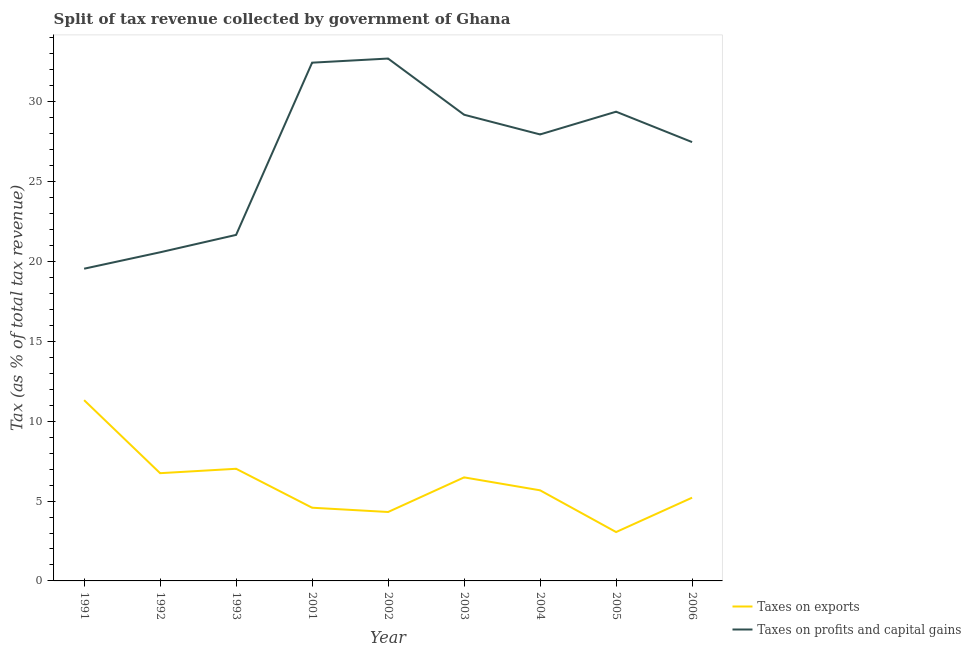How many different coloured lines are there?
Provide a succinct answer. 2. What is the percentage of revenue obtained from taxes on profits and capital gains in 1991?
Keep it short and to the point. 19.55. Across all years, what is the maximum percentage of revenue obtained from taxes on exports?
Provide a succinct answer. 11.32. Across all years, what is the minimum percentage of revenue obtained from taxes on profits and capital gains?
Your answer should be compact. 19.55. In which year was the percentage of revenue obtained from taxes on exports maximum?
Ensure brevity in your answer.  1991. What is the total percentage of revenue obtained from taxes on exports in the graph?
Offer a terse response. 54.41. What is the difference between the percentage of revenue obtained from taxes on exports in 1991 and that in 2005?
Provide a short and direct response. 8.26. What is the difference between the percentage of revenue obtained from taxes on exports in 1991 and the percentage of revenue obtained from taxes on profits and capital gains in 1993?
Give a very brief answer. -10.35. What is the average percentage of revenue obtained from taxes on exports per year?
Your answer should be compact. 6.05. In the year 1993, what is the difference between the percentage of revenue obtained from taxes on exports and percentage of revenue obtained from taxes on profits and capital gains?
Provide a short and direct response. -14.64. In how many years, is the percentage of revenue obtained from taxes on exports greater than 28 %?
Keep it short and to the point. 0. What is the ratio of the percentage of revenue obtained from taxes on profits and capital gains in 1993 to that in 2006?
Your answer should be compact. 0.79. Is the difference between the percentage of revenue obtained from taxes on exports in 1993 and 2005 greater than the difference between the percentage of revenue obtained from taxes on profits and capital gains in 1993 and 2005?
Give a very brief answer. Yes. What is the difference between the highest and the second highest percentage of revenue obtained from taxes on exports?
Make the answer very short. 4.3. What is the difference between the highest and the lowest percentage of revenue obtained from taxes on profits and capital gains?
Ensure brevity in your answer.  13.16. In how many years, is the percentage of revenue obtained from taxes on exports greater than the average percentage of revenue obtained from taxes on exports taken over all years?
Provide a succinct answer. 4. Does the percentage of revenue obtained from taxes on profits and capital gains monotonically increase over the years?
Make the answer very short. No. Is the percentage of revenue obtained from taxes on exports strictly greater than the percentage of revenue obtained from taxes on profits and capital gains over the years?
Ensure brevity in your answer.  No. Is the percentage of revenue obtained from taxes on exports strictly less than the percentage of revenue obtained from taxes on profits and capital gains over the years?
Give a very brief answer. Yes. How many lines are there?
Offer a terse response. 2. Does the graph contain grids?
Provide a short and direct response. No. Where does the legend appear in the graph?
Keep it short and to the point. Bottom right. How many legend labels are there?
Offer a terse response. 2. How are the legend labels stacked?
Ensure brevity in your answer.  Vertical. What is the title of the graph?
Your answer should be very brief. Split of tax revenue collected by government of Ghana. What is the label or title of the Y-axis?
Your answer should be compact. Tax (as % of total tax revenue). What is the Tax (as % of total tax revenue) of Taxes on exports in 1991?
Keep it short and to the point. 11.32. What is the Tax (as % of total tax revenue) in Taxes on profits and capital gains in 1991?
Keep it short and to the point. 19.55. What is the Tax (as % of total tax revenue) in Taxes on exports in 1992?
Your response must be concise. 6.75. What is the Tax (as % of total tax revenue) in Taxes on profits and capital gains in 1992?
Offer a very short reply. 20.57. What is the Tax (as % of total tax revenue) in Taxes on exports in 1993?
Provide a short and direct response. 7.02. What is the Tax (as % of total tax revenue) of Taxes on profits and capital gains in 1993?
Keep it short and to the point. 21.66. What is the Tax (as % of total tax revenue) of Taxes on exports in 2001?
Provide a short and direct response. 4.58. What is the Tax (as % of total tax revenue) of Taxes on profits and capital gains in 2001?
Provide a short and direct response. 32.45. What is the Tax (as % of total tax revenue) in Taxes on exports in 2002?
Provide a short and direct response. 4.32. What is the Tax (as % of total tax revenue) in Taxes on profits and capital gains in 2002?
Keep it short and to the point. 32.7. What is the Tax (as % of total tax revenue) of Taxes on exports in 2003?
Provide a succinct answer. 6.48. What is the Tax (as % of total tax revenue) in Taxes on profits and capital gains in 2003?
Give a very brief answer. 29.19. What is the Tax (as % of total tax revenue) in Taxes on exports in 2004?
Provide a succinct answer. 5.67. What is the Tax (as % of total tax revenue) of Taxes on profits and capital gains in 2004?
Ensure brevity in your answer.  27.95. What is the Tax (as % of total tax revenue) in Taxes on exports in 2005?
Your answer should be very brief. 3.06. What is the Tax (as % of total tax revenue) in Taxes on profits and capital gains in 2005?
Offer a very short reply. 29.38. What is the Tax (as % of total tax revenue) in Taxes on exports in 2006?
Offer a very short reply. 5.21. What is the Tax (as % of total tax revenue) of Taxes on profits and capital gains in 2006?
Keep it short and to the point. 27.47. Across all years, what is the maximum Tax (as % of total tax revenue) of Taxes on exports?
Ensure brevity in your answer.  11.32. Across all years, what is the maximum Tax (as % of total tax revenue) in Taxes on profits and capital gains?
Your answer should be compact. 32.7. Across all years, what is the minimum Tax (as % of total tax revenue) of Taxes on exports?
Make the answer very short. 3.06. Across all years, what is the minimum Tax (as % of total tax revenue) of Taxes on profits and capital gains?
Offer a very short reply. 19.55. What is the total Tax (as % of total tax revenue) of Taxes on exports in the graph?
Offer a terse response. 54.41. What is the total Tax (as % of total tax revenue) of Taxes on profits and capital gains in the graph?
Make the answer very short. 240.93. What is the difference between the Tax (as % of total tax revenue) in Taxes on exports in 1991 and that in 1992?
Offer a very short reply. 4.57. What is the difference between the Tax (as % of total tax revenue) of Taxes on profits and capital gains in 1991 and that in 1992?
Your answer should be very brief. -1.03. What is the difference between the Tax (as % of total tax revenue) in Taxes on exports in 1991 and that in 1993?
Your answer should be very brief. 4.3. What is the difference between the Tax (as % of total tax revenue) of Taxes on profits and capital gains in 1991 and that in 1993?
Give a very brief answer. -2.12. What is the difference between the Tax (as % of total tax revenue) in Taxes on exports in 1991 and that in 2001?
Offer a very short reply. 6.73. What is the difference between the Tax (as % of total tax revenue) in Taxes on profits and capital gains in 1991 and that in 2001?
Provide a succinct answer. -12.9. What is the difference between the Tax (as % of total tax revenue) of Taxes on exports in 1991 and that in 2002?
Your response must be concise. 7. What is the difference between the Tax (as % of total tax revenue) in Taxes on profits and capital gains in 1991 and that in 2002?
Keep it short and to the point. -13.16. What is the difference between the Tax (as % of total tax revenue) of Taxes on exports in 1991 and that in 2003?
Ensure brevity in your answer.  4.83. What is the difference between the Tax (as % of total tax revenue) of Taxes on profits and capital gains in 1991 and that in 2003?
Keep it short and to the point. -9.64. What is the difference between the Tax (as % of total tax revenue) of Taxes on exports in 1991 and that in 2004?
Provide a short and direct response. 5.64. What is the difference between the Tax (as % of total tax revenue) of Taxes on profits and capital gains in 1991 and that in 2004?
Offer a very short reply. -8.41. What is the difference between the Tax (as % of total tax revenue) of Taxes on exports in 1991 and that in 2005?
Give a very brief answer. 8.26. What is the difference between the Tax (as % of total tax revenue) of Taxes on profits and capital gains in 1991 and that in 2005?
Make the answer very short. -9.83. What is the difference between the Tax (as % of total tax revenue) of Taxes on exports in 1991 and that in 2006?
Your answer should be compact. 6.11. What is the difference between the Tax (as % of total tax revenue) of Taxes on profits and capital gains in 1991 and that in 2006?
Provide a succinct answer. -7.93. What is the difference between the Tax (as % of total tax revenue) in Taxes on exports in 1992 and that in 1993?
Offer a terse response. -0.28. What is the difference between the Tax (as % of total tax revenue) in Taxes on profits and capital gains in 1992 and that in 1993?
Provide a short and direct response. -1.09. What is the difference between the Tax (as % of total tax revenue) of Taxes on exports in 1992 and that in 2001?
Keep it short and to the point. 2.16. What is the difference between the Tax (as % of total tax revenue) of Taxes on profits and capital gains in 1992 and that in 2001?
Give a very brief answer. -11.87. What is the difference between the Tax (as % of total tax revenue) in Taxes on exports in 1992 and that in 2002?
Offer a very short reply. 2.43. What is the difference between the Tax (as % of total tax revenue) of Taxes on profits and capital gains in 1992 and that in 2002?
Your answer should be very brief. -12.13. What is the difference between the Tax (as % of total tax revenue) in Taxes on exports in 1992 and that in 2003?
Your answer should be compact. 0.26. What is the difference between the Tax (as % of total tax revenue) of Taxes on profits and capital gains in 1992 and that in 2003?
Provide a succinct answer. -8.61. What is the difference between the Tax (as % of total tax revenue) of Taxes on exports in 1992 and that in 2004?
Your response must be concise. 1.07. What is the difference between the Tax (as % of total tax revenue) in Taxes on profits and capital gains in 1992 and that in 2004?
Offer a very short reply. -7.38. What is the difference between the Tax (as % of total tax revenue) in Taxes on exports in 1992 and that in 2005?
Your response must be concise. 3.69. What is the difference between the Tax (as % of total tax revenue) of Taxes on profits and capital gains in 1992 and that in 2005?
Make the answer very short. -8.8. What is the difference between the Tax (as % of total tax revenue) in Taxes on exports in 1992 and that in 2006?
Your answer should be compact. 1.53. What is the difference between the Tax (as % of total tax revenue) in Taxes on profits and capital gains in 1992 and that in 2006?
Offer a very short reply. -6.9. What is the difference between the Tax (as % of total tax revenue) in Taxes on exports in 1993 and that in 2001?
Offer a very short reply. 2.44. What is the difference between the Tax (as % of total tax revenue) in Taxes on profits and capital gains in 1993 and that in 2001?
Keep it short and to the point. -10.78. What is the difference between the Tax (as % of total tax revenue) in Taxes on exports in 1993 and that in 2002?
Your answer should be very brief. 2.71. What is the difference between the Tax (as % of total tax revenue) in Taxes on profits and capital gains in 1993 and that in 2002?
Your response must be concise. -11.04. What is the difference between the Tax (as % of total tax revenue) in Taxes on exports in 1993 and that in 2003?
Provide a short and direct response. 0.54. What is the difference between the Tax (as % of total tax revenue) in Taxes on profits and capital gains in 1993 and that in 2003?
Provide a succinct answer. -7.52. What is the difference between the Tax (as % of total tax revenue) of Taxes on exports in 1993 and that in 2004?
Keep it short and to the point. 1.35. What is the difference between the Tax (as % of total tax revenue) of Taxes on profits and capital gains in 1993 and that in 2004?
Offer a terse response. -6.29. What is the difference between the Tax (as % of total tax revenue) in Taxes on exports in 1993 and that in 2005?
Your response must be concise. 3.96. What is the difference between the Tax (as % of total tax revenue) in Taxes on profits and capital gains in 1993 and that in 2005?
Your response must be concise. -7.71. What is the difference between the Tax (as % of total tax revenue) of Taxes on exports in 1993 and that in 2006?
Offer a very short reply. 1.81. What is the difference between the Tax (as % of total tax revenue) in Taxes on profits and capital gains in 1993 and that in 2006?
Your answer should be compact. -5.81. What is the difference between the Tax (as % of total tax revenue) in Taxes on exports in 2001 and that in 2002?
Ensure brevity in your answer.  0.27. What is the difference between the Tax (as % of total tax revenue) in Taxes on profits and capital gains in 2001 and that in 2002?
Keep it short and to the point. -0.26. What is the difference between the Tax (as % of total tax revenue) of Taxes on exports in 2001 and that in 2003?
Your answer should be compact. -1.9. What is the difference between the Tax (as % of total tax revenue) of Taxes on profits and capital gains in 2001 and that in 2003?
Keep it short and to the point. 3.26. What is the difference between the Tax (as % of total tax revenue) of Taxes on exports in 2001 and that in 2004?
Provide a succinct answer. -1.09. What is the difference between the Tax (as % of total tax revenue) in Taxes on profits and capital gains in 2001 and that in 2004?
Make the answer very short. 4.49. What is the difference between the Tax (as % of total tax revenue) of Taxes on exports in 2001 and that in 2005?
Offer a very short reply. 1.52. What is the difference between the Tax (as % of total tax revenue) of Taxes on profits and capital gains in 2001 and that in 2005?
Provide a short and direct response. 3.07. What is the difference between the Tax (as % of total tax revenue) of Taxes on exports in 2001 and that in 2006?
Make the answer very short. -0.63. What is the difference between the Tax (as % of total tax revenue) of Taxes on profits and capital gains in 2001 and that in 2006?
Offer a terse response. 4.97. What is the difference between the Tax (as % of total tax revenue) in Taxes on exports in 2002 and that in 2003?
Your answer should be very brief. -2.17. What is the difference between the Tax (as % of total tax revenue) in Taxes on profits and capital gains in 2002 and that in 2003?
Ensure brevity in your answer.  3.52. What is the difference between the Tax (as % of total tax revenue) of Taxes on exports in 2002 and that in 2004?
Your answer should be compact. -1.36. What is the difference between the Tax (as % of total tax revenue) in Taxes on profits and capital gains in 2002 and that in 2004?
Offer a very short reply. 4.75. What is the difference between the Tax (as % of total tax revenue) in Taxes on exports in 2002 and that in 2005?
Ensure brevity in your answer.  1.26. What is the difference between the Tax (as % of total tax revenue) of Taxes on profits and capital gains in 2002 and that in 2005?
Your response must be concise. 3.33. What is the difference between the Tax (as % of total tax revenue) in Taxes on exports in 2002 and that in 2006?
Give a very brief answer. -0.9. What is the difference between the Tax (as % of total tax revenue) of Taxes on profits and capital gains in 2002 and that in 2006?
Provide a succinct answer. 5.23. What is the difference between the Tax (as % of total tax revenue) of Taxes on exports in 2003 and that in 2004?
Offer a very short reply. 0.81. What is the difference between the Tax (as % of total tax revenue) of Taxes on profits and capital gains in 2003 and that in 2004?
Your answer should be very brief. 1.23. What is the difference between the Tax (as % of total tax revenue) of Taxes on exports in 2003 and that in 2005?
Offer a very short reply. 3.42. What is the difference between the Tax (as % of total tax revenue) in Taxes on profits and capital gains in 2003 and that in 2005?
Ensure brevity in your answer.  -0.19. What is the difference between the Tax (as % of total tax revenue) of Taxes on exports in 2003 and that in 2006?
Provide a succinct answer. 1.27. What is the difference between the Tax (as % of total tax revenue) of Taxes on profits and capital gains in 2003 and that in 2006?
Give a very brief answer. 1.71. What is the difference between the Tax (as % of total tax revenue) in Taxes on exports in 2004 and that in 2005?
Your answer should be compact. 2.61. What is the difference between the Tax (as % of total tax revenue) of Taxes on profits and capital gains in 2004 and that in 2005?
Offer a very short reply. -1.42. What is the difference between the Tax (as % of total tax revenue) in Taxes on exports in 2004 and that in 2006?
Offer a terse response. 0.46. What is the difference between the Tax (as % of total tax revenue) in Taxes on profits and capital gains in 2004 and that in 2006?
Your answer should be very brief. 0.48. What is the difference between the Tax (as % of total tax revenue) in Taxes on exports in 2005 and that in 2006?
Offer a terse response. -2.15. What is the difference between the Tax (as % of total tax revenue) in Taxes on profits and capital gains in 2005 and that in 2006?
Ensure brevity in your answer.  1.9. What is the difference between the Tax (as % of total tax revenue) in Taxes on exports in 1991 and the Tax (as % of total tax revenue) in Taxes on profits and capital gains in 1992?
Provide a short and direct response. -9.26. What is the difference between the Tax (as % of total tax revenue) of Taxes on exports in 1991 and the Tax (as % of total tax revenue) of Taxes on profits and capital gains in 1993?
Offer a terse response. -10.35. What is the difference between the Tax (as % of total tax revenue) of Taxes on exports in 1991 and the Tax (as % of total tax revenue) of Taxes on profits and capital gains in 2001?
Your response must be concise. -21.13. What is the difference between the Tax (as % of total tax revenue) in Taxes on exports in 1991 and the Tax (as % of total tax revenue) in Taxes on profits and capital gains in 2002?
Offer a terse response. -21.39. What is the difference between the Tax (as % of total tax revenue) of Taxes on exports in 1991 and the Tax (as % of total tax revenue) of Taxes on profits and capital gains in 2003?
Your answer should be compact. -17.87. What is the difference between the Tax (as % of total tax revenue) in Taxes on exports in 1991 and the Tax (as % of total tax revenue) in Taxes on profits and capital gains in 2004?
Ensure brevity in your answer.  -16.64. What is the difference between the Tax (as % of total tax revenue) in Taxes on exports in 1991 and the Tax (as % of total tax revenue) in Taxes on profits and capital gains in 2005?
Your answer should be compact. -18.06. What is the difference between the Tax (as % of total tax revenue) of Taxes on exports in 1991 and the Tax (as % of total tax revenue) of Taxes on profits and capital gains in 2006?
Offer a terse response. -16.16. What is the difference between the Tax (as % of total tax revenue) in Taxes on exports in 1992 and the Tax (as % of total tax revenue) in Taxes on profits and capital gains in 1993?
Give a very brief answer. -14.92. What is the difference between the Tax (as % of total tax revenue) of Taxes on exports in 1992 and the Tax (as % of total tax revenue) of Taxes on profits and capital gains in 2001?
Your answer should be compact. -25.7. What is the difference between the Tax (as % of total tax revenue) of Taxes on exports in 1992 and the Tax (as % of total tax revenue) of Taxes on profits and capital gains in 2002?
Provide a short and direct response. -25.96. What is the difference between the Tax (as % of total tax revenue) of Taxes on exports in 1992 and the Tax (as % of total tax revenue) of Taxes on profits and capital gains in 2003?
Give a very brief answer. -22.44. What is the difference between the Tax (as % of total tax revenue) in Taxes on exports in 1992 and the Tax (as % of total tax revenue) in Taxes on profits and capital gains in 2004?
Your response must be concise. -21.21. What is the difference between the Tax (as % of total tax revenue) in Taxes on exports in 1992 and the Tax (as % of total tax revenue) in Taxes on profits and capital gains in 2005?
Provide a succinct answer. -22.63. What is the difference between the Tax (as % of total tax revenue) in Taxes on exports in 1992 and the Tax (as % of total tax revenue) in Taxes on profits and capital gains in 2006?
Provide a short and direct response. -20.73. What is the difference between the Tax (as % of total tax revenue) in Taxes on exports in 1993 and the Tax (as % of total tax revenue) in Taxes on profits and capital gains in 2001?
Provide a succinct answer. -25.43. What is the difference between the Tax (as % of total tax revenue) of Taxes on exports in 1993 and the Tax (as % of total tax revenue) of Taxes on profits and capital gains in 2002?
Ensure brevity in your answer.  -25.68. What is the difference between the Tax (as % of total tax revenue) in Taxes on exports in 1993 and the Tax (as % of total tax revenue) in Taxes on profits and capital gains in 2003?
Provide a short and direct response. -22.17. What is the difference between the Tax (as % of total tax revenue) of Taxes on exports in 1993 and the Tax (as % of total tax revenue) of Taxes on profits and capital gains in 2004?
Make the answer very short. -20.93. What is the difference between the Tax (as % of total tax revenue) in Taxes on exports in 1993 and the Tax (as % of total tax revenue) in Taxes on profits and capital gains in 2005?
Your answer should be compact. -22.36. What is the difference between the Tax (as % of total tax revenue) of Taxes on exports in 1993 and the Tax (as % of total tax revenue) of Taxes on profits and capital gains in 2006?
Make the answer very short. -20.45. What is the difference between the Tax (as % of total tax revenue) of Taxes on exports in 2001 and the Tax (as % of total tax revenue) of Taxes on profits and capital gains in 2002?
Ensure brevity in your answer.  -28.12. What is the difference between the Tax (as % of total tax revenue) of Taxes on exports in 2001 and the Tax (as % of total tax revenue) of Taxes on profits and capital gains in 2003?
Your answer should be very brief. -24.6. What is the difference between the Tax (as % of total tax revenue) in Taxes on exports in 2001 and the Tax (as % of total tax revenue) in Taxes on profits and capital gains in 2004?
Keep it short and to the point. -23.37. What is the difference between the Tax (as % of total tax revenue) of Taxes on exports in 2001 and the Tax (as % of total tax revenue) of Taxes on profits and capital gains in 2005?
Keep it short and to the point. -24.79. What is the difference between the Tax (as % of total tax revenue) of Taxes on exports in 2001 and the Tax (as % of total tax revenue) of Taxes on profits and capital gains in 2006?
Keep it short and to the point. -22.89. What is the difference between the Tax (as % of total tax revenue) in Taxes on exports in 2002 and the Tax (as % of total tax revenue) in Taxes on profits and capital gains in 2003?
Make the answer very short. -24.87. What is the difference between the Tax (as % of total tax revenue) in Taxes on exports in 2002 and the Tax (as % of total tax revenue) in Taxes on profits and capital gains in 2004?
Keep it short and to the point. -23.64. What is the difference between the Tax (as % of total tax revenue) in Taxes on exports in 2002 and the Tax (as % of total tax revenue) in Taxes on profits and capital gains in 2005?
Offer a terse response. -25.06. What is the difference between the Tax (as % of total tax revenue) of Taxes on exports in 2002 and the Tax (as % of total tax revenue) of Taxes on profits and capital gains in 2006?
Your answer should be very brief. -23.16. What is the difference between the Tax (as % of total tax revenue) of Taxes on exports in 2003 and the Tax (as % of total tax revenue) of Taxes on profits and capital gains in 2004?
Your response must be concise. -21.47. What is the difference between the Tax (as % of total tax revenue) in Taxes on exports in 2003 and the Tax (as % of total tax revenue) in Taxes on profits and capital gains in 2005?
Provide a succinct answer. -22.89. What is the difference between the Tax (as % of total tax revenue) in Taxes on exports in 2003 and the Tax (as % of total tax revenue) in Taxes on profits and capital gains in 2006?
Give a very brief answer. -20.99. What is the difference between the Tax (as % of total tax revenue) of Taxes on exports in 2004 and the Tax (as % of total tax revenue) of Taxes on profits and capital gains in 2005?
Provide a short and direct response. -23.7. What is the difference between the Tax (as % of total tax revenue) in Taxes on exports in 2004 and the Tax (as % of total tax revenue) in Taxes on profits and capital gains in 2006?
Give a very brief answer. -21.8. What is the difference between the Tax (as % of total tax revenue) of Taxes on exports in 2005 and the Tax (as % of total tax revenue) of Taxes on profits and capital gains in 2006?
Keep it short and to the point. -24.41. What is the average Tax (as % of total tax revenue) in Taxes on exports per year?
Offer a terse response. 6.05. What is the average Tax (as % of total tax revenue) in Taxes on profits and capital gains per year?
Your answer should be compact. 26.77. In the year 1991, what is the difference between the Tax (as % of total tax revenue) in Taxes on exports and Tax (as % of total tax revenue) in Taxes on profits and capital gains?
Provide a succinct answer. -8.23. In the year 1992, what is the difference between the Tax (as % of total tax revenue) in Taxes on exports and Tax (as % of total tax revenue) in Taxes on profits and capital gains?
Provide a succinct answer. -13.83. In the year 1993, what is the difference between the Tax (as % of total tax revenue) of Taxes on exports and Tax (as % of total tax revenue) of Taxes on profits and capital gains?
Offer a terse response. -14.64. In the year 2001, what is the difference between the Tax (as % of total tax revenue) in Taxes on exports and Tax (as % of total tax revenue) in Taxes on profits and capital gains?
Offer a very short reply. -27.86. In the year 2002, what is the difference between the Tax (as % of total tax revenue) in Taxes on exports and Tax (as % of total tax revenue) in Taxes on profits and capital gains?
Ensure brevity in your answer.  -28.39. In the year 2003, what is the difference between the Tax (as % of total tax revenue) in Taxes on exports and Tax (as % of total tax revenue) in Taxes on profits and capital gains?
Provide a succinct answer. -22.7. In the year 2004, what is the difference between the Tax (as % of total tax revenue) in Taxes on exports and Tax (as % of total tax revenue) in Taxes on profits and capital gains?
Give a very brief answer. -22.28. In the year 2005, what is the difference between the Tax (as % of total tax revenue) of Taxes on exports and Tax (as % of total tax revenue) of Taxes on profits and capital gains?
Give a very brief answer. -26.32. In the year 2006, what is the difference between the Tax (as % of total tax revenue) of Taxes on exports and Tax (as % of total tax revenue) of Taxes on profits and capital gains?
Provide a short and direct response. -22.26. What is the ratio of the Tax (as % of total tax revenue) of Taxes on exports in 1991 to that in 1992?
Your answer should be compact. 1.68. What is the ratio of the Tax (as % of total tax revenue) of Taxes on profits and capital gains in 1991 to that in 1992?
Ensure brevity in your answer.  0.95. What is the ratio of the Tax (as % of total tax revenue) in Taxes on exports in 1991 to that in 1993?
Give a very brief answer. 1.61. What is the ratio of the Tax (as % of total tax revenue) in Taxes on profits and capital gains in 1991 to that in 1993?
Ensure brevity in your answer.  0.9. What is the ratio of the Tax (as % of total tax revenue) in Taxes on exports in 1991 to that in 2001?
Your response must be concise. 2.47. What is the ratio of the Tax (as % of total tax revenue) in Taxes on profits and capital gains in 1991 to that in 2001?
Give a very brief answer. 0.6. What is the ratio of the Tax (as % of total tax revenue) of Taxes on exports in 1991 to that in 2002?
Make the answer very short. 2.62. What is the ratio of the Tax (as % of total tax revenue) in Taxes on profits and capital gains in 1991 to that in 2002?
Give a very brief answer. 0.6. What is the ratio of the Tax (as % of total tax revenue) in Taxes on exports in 1991 to that in 2003?
Keep it short and to the point. 1.75. What is the ratio of the Tax (as % of total tax revenue) in Taxes on profits and capital gains in 1991 to that in 2003?
Offer a terse response. 0.67. What is the ratio of the Tax (as % of total tax revenue) in Taxes on exports in 1991 to that in 2004?
Offer a very short reply. 1.99. What is the ratio of the Tax (as % of total tax revenue) in Taxes on profits and capital gains in 1991 to that in 2004?
Provide a short and direct response. 0.7. What is the ratio of the Tax (as % of total tax revenue) of Taxes on exports in 1991 to that in 2005?
Make the answer very short. 3.7. What is the ratio of the Tax (as % of total tax revenue) of Taxes on profits and capital gains in 1991 to that in 2005?
Give a very brief answer. 0.67. What is the ratio of the Tax (as % of total tax revenue) in Taxes on exports in 1991 to that in 2006?
Provide a succinct answer. 2.17. What is the ratio of the Tax (as % of total tax revenue) in Taxes on profits and capital gains in 1991 to that in 2006?
Your response must be concise. 0.71. What is the ratio of the Tax (as % of total tax revenue) in Taxes on exports in 1992 to that in 1993?
Make the answer very short. 0.96. What is the ratio of the Tax (as % of total tax revenue) of Taxes on profits and capital gains in 1992 to that in 1993?
Offer a very short reply. 0.95. What is the ratio of the Tax (as % of total tax revenue) of Taxes on exports in 1992 to that in 2001?
Your answer should be compact. 1.47. What is the ratio of the Tax (as % of total tax revenue) in Taxes on profits and capital gains in 1992 to that in 2001?
Your response must be concise. 0.63. What is the ratio of the Tax (as % of total tax revenue) of Taxes on exports in 1992 to that in 2002?
Provide a succinct answer. 1.56. What is the ratio of the Tax (as % of total tax revenue) in Taxes on profits and capital gains in 1992 to that in 2002?
Keep it short and to the point. 0.63. What is the ratio of the Tax (as % of total tax revenue) in Taxes on exports in 1992 to that in 2003?
Offer a terse response. 1.04. What is the ratio of the Tax (as % of total tax revenue) of Taxes on profits and capital gains in 1992 to that in 2003?
Provide a succinct answer. 0.7. What is the ratio of the Tax (as % of total tax revenue) in Taxes on exports in 1992 to that in 2004?
Provide a succinct answer. 1.19. What is the ratio of the Tax (as % of total tax revenue) in Taxes on profits and capital gains in 1992 to that in 2004?
Offer a very short reply. 0.74. What is the ratio of the Tax (as % of total tax revenue) in Taxes on exports in 1992 to that in 2005?
Keep it short and to the point. 2.2. What is the ratio of the Tax (as % of total tax revenue) in Taxes on profits and capital gains in 1992 to that in 2005?
Provide a succinct answer. 0.7. What is the ratio of the Tax (as % of total tax revenue) in Taxes on exports in 1992 to that in 2006?
Your response must be concise. 1.29. What is the ratio of the Tax (as % of total tax revenue) in Taxes on profits and capital gains in 1992 to that in 2006?
Keep it short and to the point. 0.75. What is the ratio of the Tax (as % of total tax revenue) of Taxes on exports in 1993 to that in 2001?
Provide a succinct answer. 1.53. What is the ratio of the Tax (as % of total tax revenue) of Taxes on profits and capital gains in 1993 to that in 2001?
Provide a succinct answer. 0.67. What is the ratio of the Tax (as % of total tax revenue) in Taxes on exports in 1993 to that in 2002?
Offer a very short reply. 1.63. What is the ratio of the Tax (as % of total tax revenue) in Taxes on profits and capital gains in 1993 to that in 2002?
Offer a terse response. 0.66. What is the ratio of the Tax (as % of total tax revenue) in Taxes on exports in 1993 to that in 2003?
Make the answer very short. 1.08. What is the ratio of the Tax (as % of total tax revenue) of Taxes on profits and capital gains in 1993 to that in 2003?
Provide a succinct answer. 0.74. What is the ratio of the Tax (as % of total tax revenue) in Taxes on exports in 1993 to that in 2004?
Provide a short and direct response. 1.24. What is the ratio of the Tax (as % of total tax revenue) of Taxes on profits and capital gains in 1993 to that in 2004?
Your answer should be very brief. 0.78. What is the ratio of the Tax (as % of total tax revenue) of Taxes on exports in 1993 to that in 2005?
Offer a very short reply. 2.29. What is the ratio of the Tax (as % of total tax revenue) of Taxes on profits and capital gains in 1993 to that in 2005?
Make the answer very short. 0.74. What is the ratio of the Tax (as % of total tax revenue) of Taxes on exports in 1993 to that in 2006?
Ensure brevity in your answer.  1.35. What is the ratio of the Tax (as % of total tax revenue) of Taxes on profits and capital gains in 1993 to that in 2006?
Provide a short and direct response. 0.79. What is the ratio of the Tax (as % of total tax revenue) of Taxes on exports in 2001 to that in 2002?
Provide a succinct answer. 1.06. What is the ratio of the Tax (as % of total tax revenue) in Taxes on profits and capital gains in 2001 to that in 2002?
Provide a succinct answer. 0.99. What is the ratio of the Tax (as % of total tax revenue) of Taxes on exports in 2001 to that in 2003?
Give a very brief answer. 0.71. What is the ratio of the Tax (as % of total tax revenue) of Taxes on profits and capital gains in 2001 to that in 2003?
Give a very brief answer. 1.11. What is the ratio of the Tax (as % of total tax revenue) in Taxes on exports in 2001 to that in 2004?
Provide a short and direct response. 0.81. What is the ratio of the Tax (as % of total tax revenue) in Taxes on profits and capital gains in 2001 to that in 2004?
Provide a short and direct response. 1.16. What is the ratio of the Tax (as % of total tax revenue) in Taxes on exports in 2001 to that in 2005?
Give a very brief answer. 1.5. What is the ratio of the Tax (as % of total tax revenue) in Taxes on profits and capital gains in 2001 to that in 2005?
Give a very brief answer. 1.1. What is the ratio of the Tax (as % of total tax revenue) of Taxes on exports in 2001 to that in 2006?
Give a very brief answer. 0.88. What is the ratio of the Tax (as % of total tax revenue) in Taxes on profits and capital gains in 2001 to that in 2006?
Give a very brief answer. 1.18. What is the ratio of the Tax (as % of total tax revenue) in Taxes on exports in 2002 to that in 2003?
Ensure brevity in your answer.  0.67. What is the ratio of the Tax (as % of total tax revenue) in Taxes on profits and capital gains in 2002 to that in 2003?
Keep it short and to the point. 1.12. What is the ratio of the Tax (as % of total tax revenue) in Taxes on exports in 2002 to that in 2004?
Offer a terse response. 0.76. What is the ratio of the Tax (as % of total tax revenue) in Taxes on profits and capital gains in 2002 to that in 2004?
Offer a terse response. 1.17. What is the ratio of the Tax (as % of total tax revenue) of Taxes on exports in 2002 to that in 2005?
Your answer should be very brief. 1.41. What is the ratio of the Tax (as % of total tax revenue) of Taxes on profits and capital gains in 2002 to that in 2005?
Provide a short and direct response. 1.11. What is the ratio of the Tax (as % of total tax revenue) in Taxes on exports in 2002 to that in 2006?
Your answer should be compact. 0.83. What is the ratio of the Tax (as % of total tax revenue) of Taxes on profits and capital gains in 2002 to that in 2006?
Offer a terse response. 1.19. What is the ratio of the Tax (as % of total tax revenue) of Taxes on exports in 2003 to that in 2004?
Your answer should be compact. 1.14. What is the ratio of the Tax (as % of total tax revenue) in Taxes on profits and capital gains in 2003 to that in 2004?
Give a very brief answer. 1.04. What is the ratio of the Tax (as % of total tax revenue) of Taxes on exports in 2003 to that in 2005?
Your response must be concise. 2.12. What is the ratio of the Tax (as % of total tax revenue) in Taxes on profits and capital gains in 2003 to that in 2005?
Offer a terse response. 0.99. What is the ratio of the Tax (as % of total tax revenue) of Taxes on exports in 2003 to that in 2006?
Make the answer very short. 1.24. What is the ratio of the Tax (as % of total tax revenue) in Taxes on profits and capital gains in 2003 to that in 2006?
Your answer should be compact. 1.06. What is the ratio of the Tax (as % of total tax revenue) of Taxes on exports in 2004 to that in 2005?
Provide a short and direct response. 1.85. What is the ratio of the Tax (as % of total tax revenue) of Taxes on profits and capital gains in 2004 to that in 2005?
Make the answer very short. 0.95. What is the ratio of the Tax (as % of total tax revenue) in Taxes on exports in 2004 to that in 2006?
Your answer should be compact. 1.09. What is the ratio of the Tax (as % of total tax revenue) in Taxes on profits and capital gains in 2004 to that in 2006?
Your answer should be very brief. 1.02. What is the ratio of the Tax (as % of total tax revenue) in Taxes on exports in 2005 to that in 2006?
Provide a succinct answer. 0.59. What is the ratio of the Tax (as % of total tax revenue) in Taxes on profits and capital gains in 2005 to that in 2006?
Keep it short and to the point. 1.07. What is the difference between the highest and the second highest Tax (as % of total tax revenue) in Taxes on exports?
Provide a short and direct response. 4.3. What is the difference between the highest and the second highest Tax (as % of total tax revenue) of Taxes on profits and capital gains?
Your response must be concise. 0.26. What is the difference between the highest and the lowest Tax (as % of total tax revenue) of Taxes on exports?
Offer a very short reply. 8.26. What is the difference between the highest and the lowest Tax (as % of total tax revenue) of Taxes on profits and capital gains?
Keep it short and to the point. 13.16. 